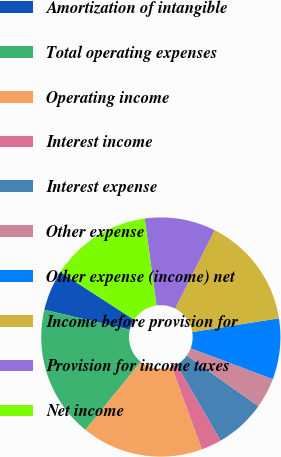<chart> <loc_0><loc_0><loc_500><loc_500><pie_chart><fcel>Amortization of intangible<fcel>Total operating expenses<fcel>Operating income<fcel>Interest income<fcel>Interest expense<fcel>Other expense<fcel>Other expense (income) net<fcel>Income before provision for<fcel>Provision for income taxes<fcel>Net income<nl><fcel>5.48%<fcel>17.81%<fcel>16.44%<fcel>2.74%<fcel>6.85%<fcel>4.11%<fcel>8.22%<fcel>15.07%<fcel>9.59%<fcel>13.7%<nl></chart> 